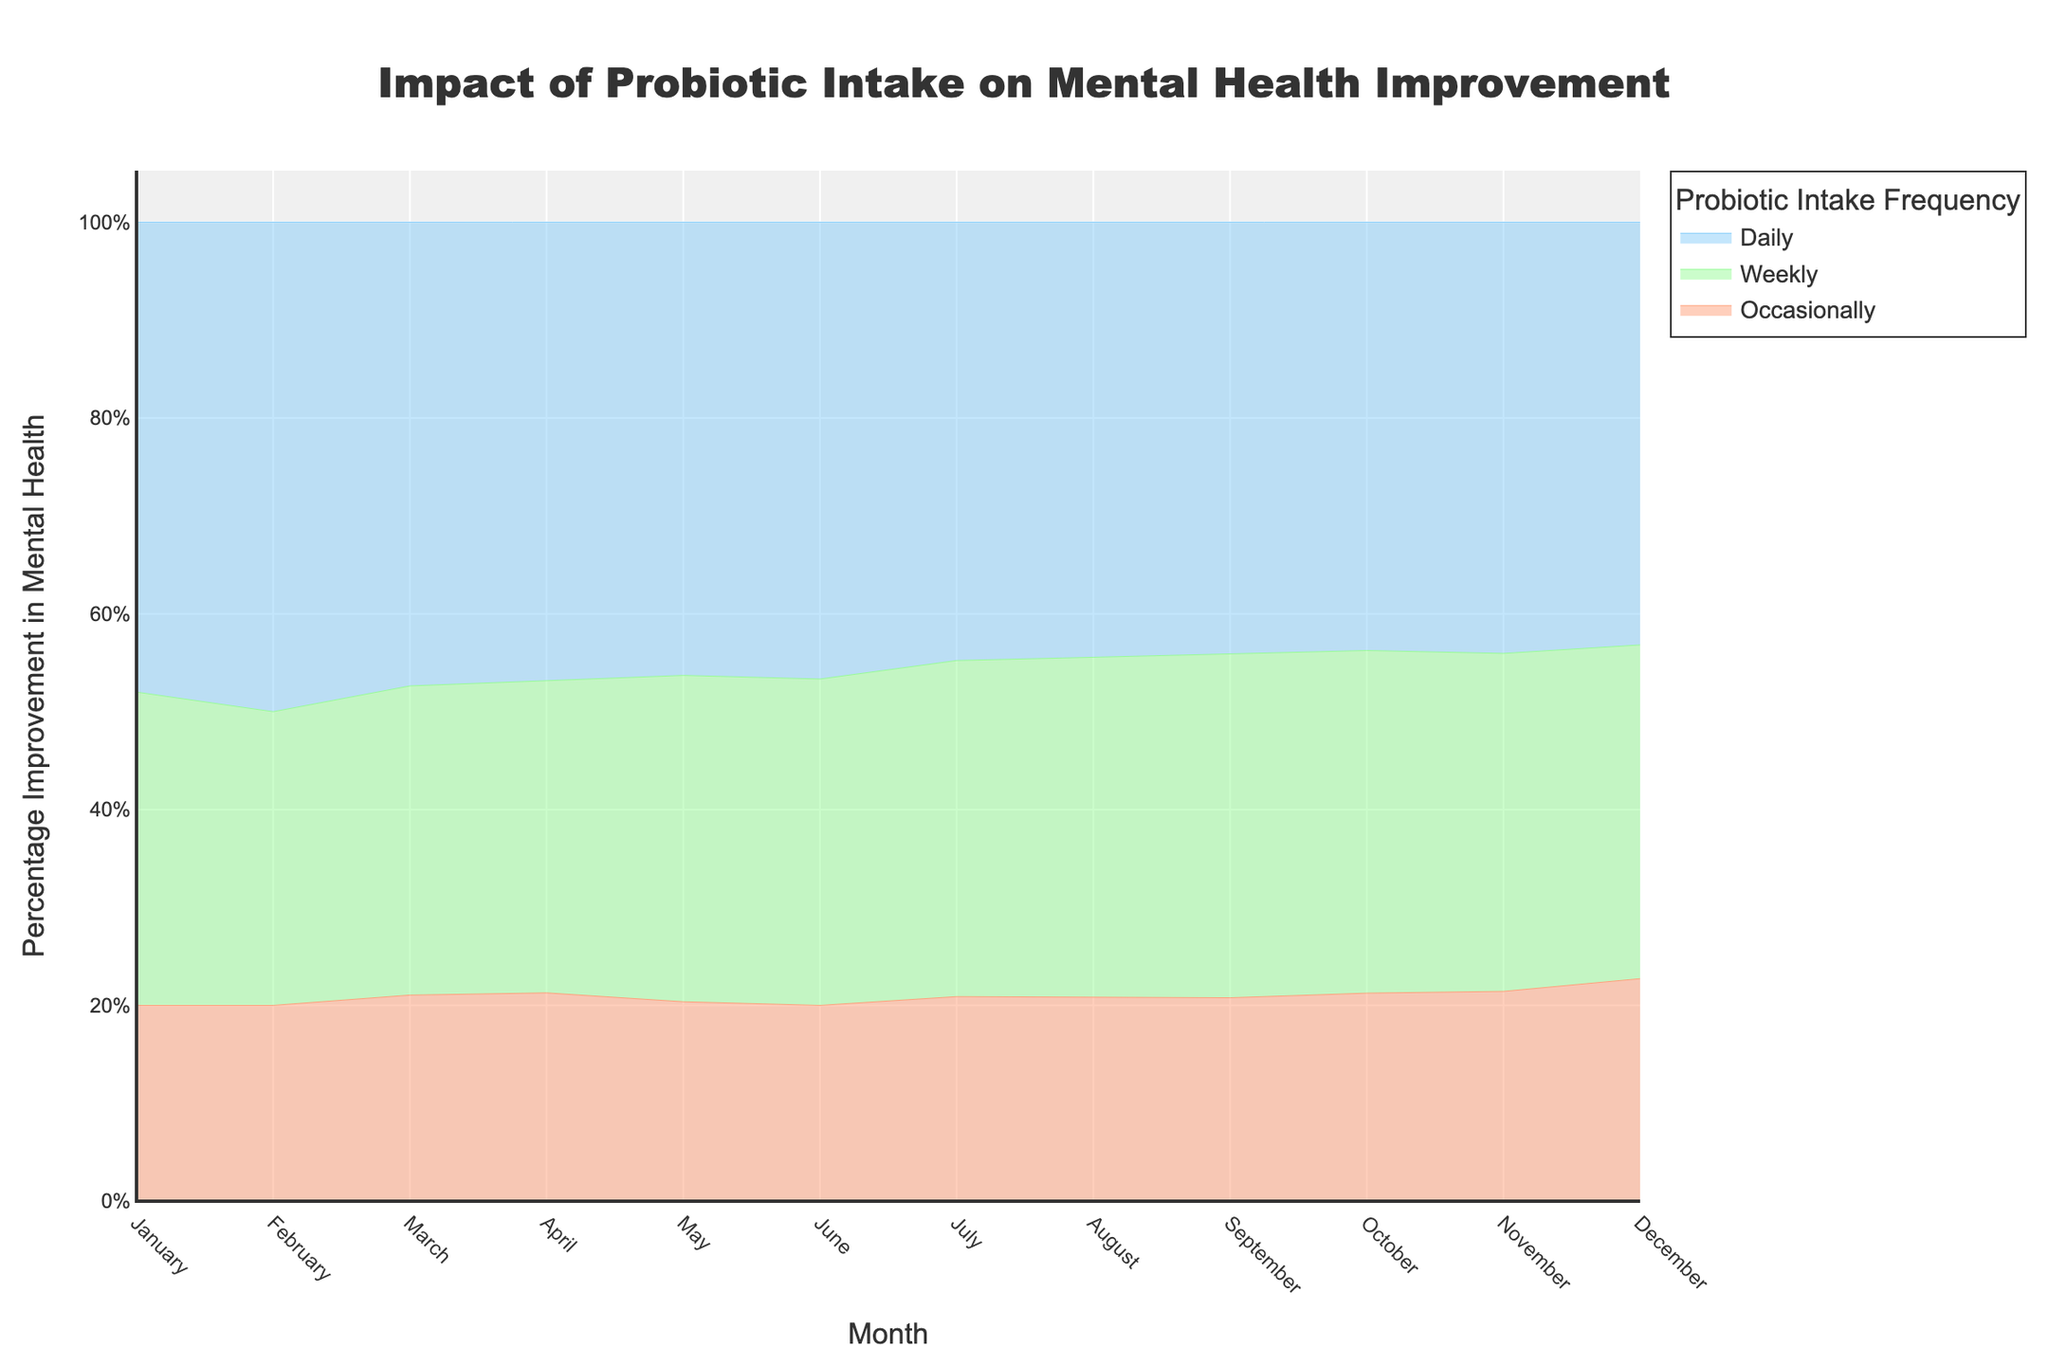What is the title of the plot? The title of the plot is at the top center and reads "Impact of Probiotic Intake on Mental Health Improvement".
Answer: Impact of Probiotic Intake on Mental Health Improvement Which month shows the highest percentage improvement for daily probiotic intake? According to the plot, December has the highest percentage improvement for daily probiotic intake, shown by the topmost segment's endpoint in December.
Answer: December What is the percentage improvement in mental health for weekly probiotic intake in June? The percentage improvement for weekly probiotic intake in June can be found by locating the June data point on the "Weekly" curve.
Answer: 20% Compare the mental health improvement difference between occasional and daily probiotic intake in September. Find the points corresponding to "Occasionally" and "Daily" probiotic intake in September and calculate the difference between them (34% - 16%).
Answer: 18% How does the trend of mental health improvement change for daily probiotic intake over the year? Daily probiotic intake shows a steadily increasing trend throughout the year, as indicated by the continuously rising line.
Answer: Increasing What is the average percentage improvement in mental health for occasional probiotic intake over the first quarter of the year? Calculate the average by adding the values for January, February, and March and then divide by 3 (5+6+8)/3.
Answer: 6.3% In which month does weekly probiotic intake first surpass a 25% improvement? By observing the curve for weekly intake, it surpasses 25% in August.
Answer: August What is the difference in mental health improvement between June and December for monthly probiotic intake? For daily intake, subtract the June value from the December value (38% - 28%).
Answer: 10% Is there a point at which all three frequencies of probiotic intake demonstrate exactly the same improvement? Upon examining the curves, there is no single point where the percentages align across all three intake frequencies.
Answer: No What color represents weekly probiotic intake on the plot? Weekly probiotic intake is depicted with a greenish color among the three colors used.
Answer: Green 